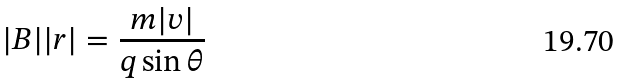Convert formula to latex. <formula><loc_0><loc_0><loc_500><loc_500>| B | | r | = \frac { m | v | } { q \sin \theta }</formula> 